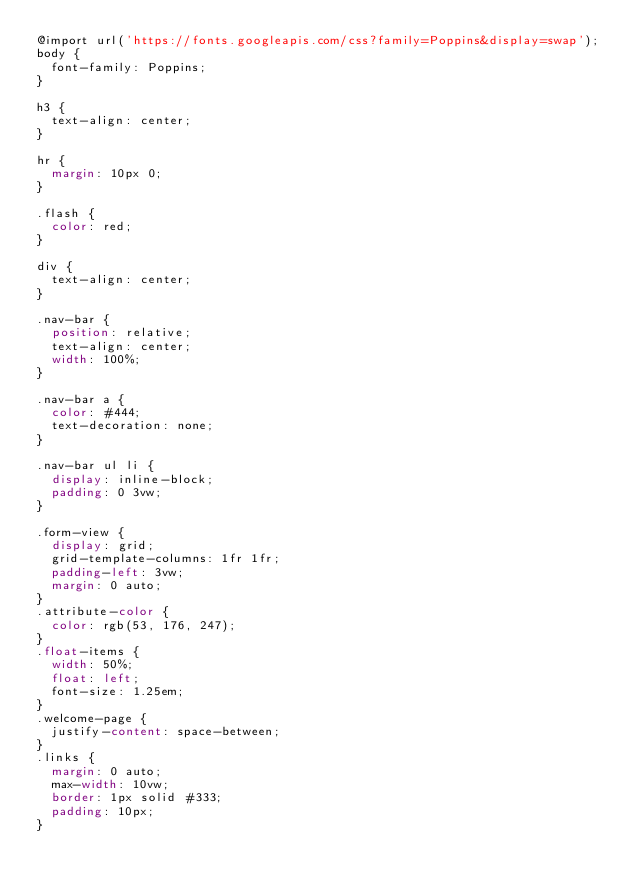Convert code to text. <code><loc_0><loc_0><loc_500><loc_500><_CSS_>@import url('https://fonts.googleapis.com/css?family=Poppins&display=swap');
body {
	font-family: Poppins;
}

h3 {
	text-align: center;
}

hr {
	margin: 10px 0;
}

.flash {
	color: red;
}

div {
	text-align: center;
}

.nav-bar {
	position: relative;
	text-align: center;
	width: 100%;
}

.nav-bar a {
	color: #444;
	text-decoration: none;
}

.nav-bar ul li {
	display: inline-block;
	padding: 0 3vw;
}

.form-view {
	display: grid;
	grid-template-columns: 1fr 1fr;
	padding-left: 3vw;
  margin: 0 auto;
}
.attribute-color {
	color: rgb(53, 176, 247);
}
.float-items {
	width: 50%;
	float: left;
	font-size: 1.25em;
}
.welcome-page {
	justify-content: space-between;
}
.links {
	margin: 0 auto;
	max-width: 10vw;
	border: 1px solid #333;
	padding: 10px;
}</code> 